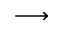<formula> <loc_0><loc_0><loc_500><loc_500>\longrightarrow</formula> 